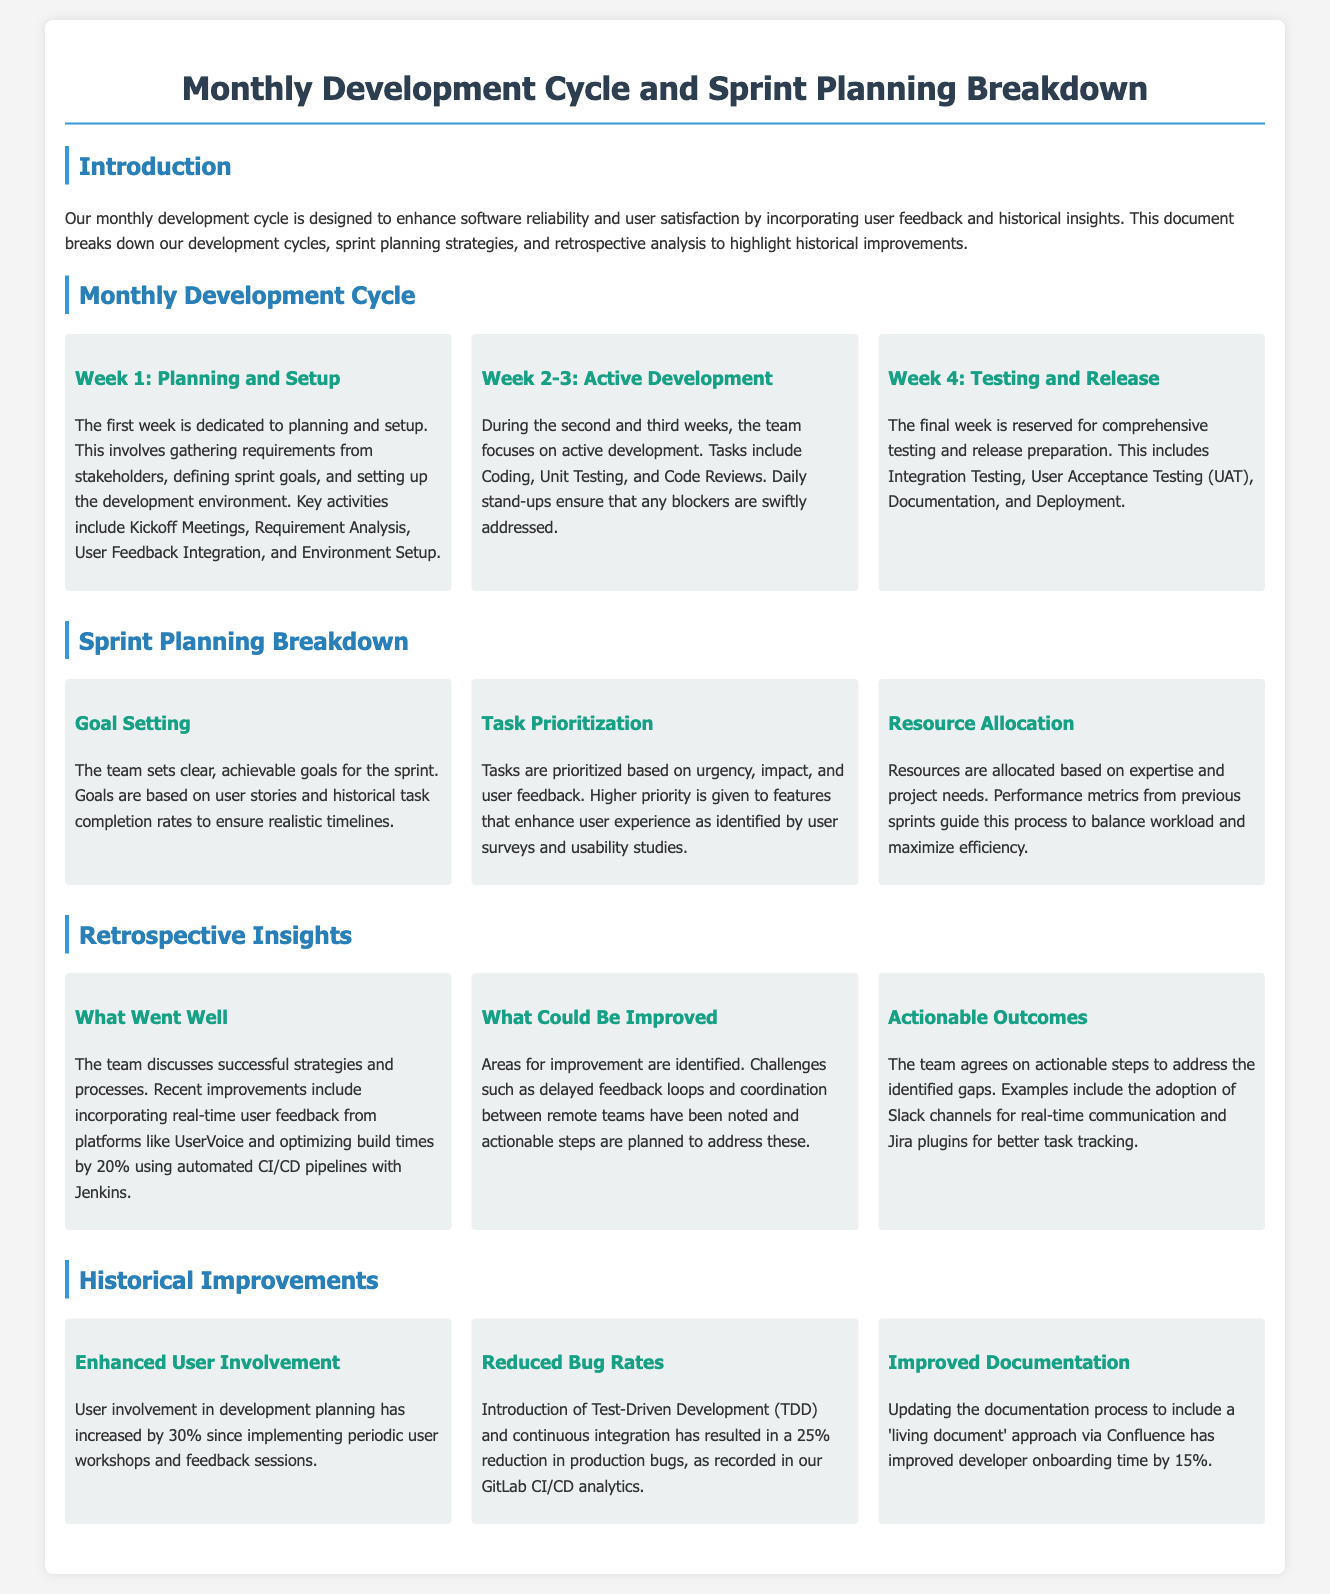What are the key activities in Week 1 of the Monthly Development Cycle? Week 1 involves gathering requirements, defining sprint goals, and setting up the development environment.
Answer: Kickoff Meetings, Requirement Analysis, User Feedback Integration, and Environment Setup What is the duration of the Active Development phase? The Active Development phase spans the second and third weeks of the Monthly Development Cycle.
Answer: Two weeks What strategy has been noted for reducing bug rates? The document states that Test-Driven Development and continuous integration are strategies used to reduce bugs.
Answer: Test-Driven Development and continuous integration What percentage reduction in bugs has been observed since implementing TDD? The document specifies a 25% reduction in production bugs due to Test-Driven Development.
Answer: 25% Which communication tool has been adopted to improve coordination? The document mentions adopting Slack channels for real-time communication.
Answer: Slack What was the increase in user involvement in development planning? It specifies a 30% increase in user involvement since implementing periodic user workshops and feedback sessions.
Answer: 30% What was one successful strategy discussed in the retrospective? The team discussed the incorporation of real-time user feedback from platforms like UserVoice as a successful strategy.
Answer: Real-time user feedback from UserVoice What is the main focus during the last week of the monthly development cycle? The last week is reserved for comprehensive testing and release preparation.
Answer: Testing and release preparation What percentage improvement in developer onboarding time has been achieved with updated documentation? The document indicates that the onboarding time improved by 15% after updating and adopting a 'living document' approach.
Answer: 15% 